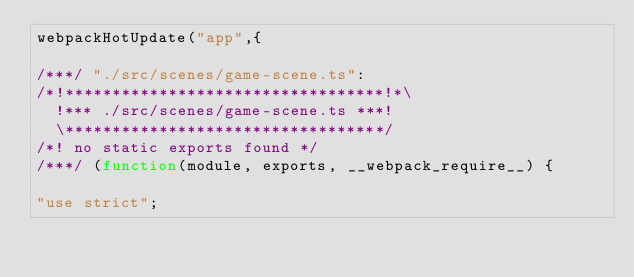<code> <loc_0><loc_0><loc_500><loc_500><_JavaScript_>webpackHotUpdate("app",{

/***/ "./src/scenes/game-scene.ts":
/*!**********************************!*\
  !*** ./src/scenes/game-scene.ts ***!
  \**********************************/
/*! no static exports found */
/***/ (function(module, exports, __webpack_require__) {

"use strict";</code> 